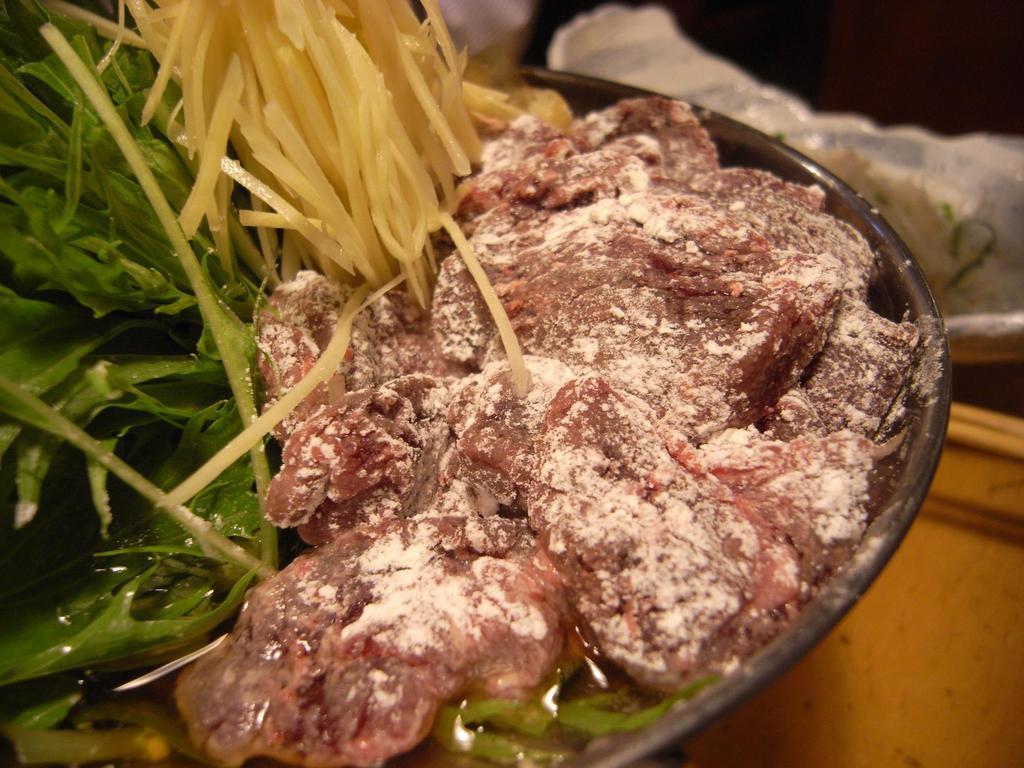In one or two sentences, can you explain what this image depicts? In this picture we can see food items in a bowl and this bowl is placed on a table and beside this bowl we can see some objects. 